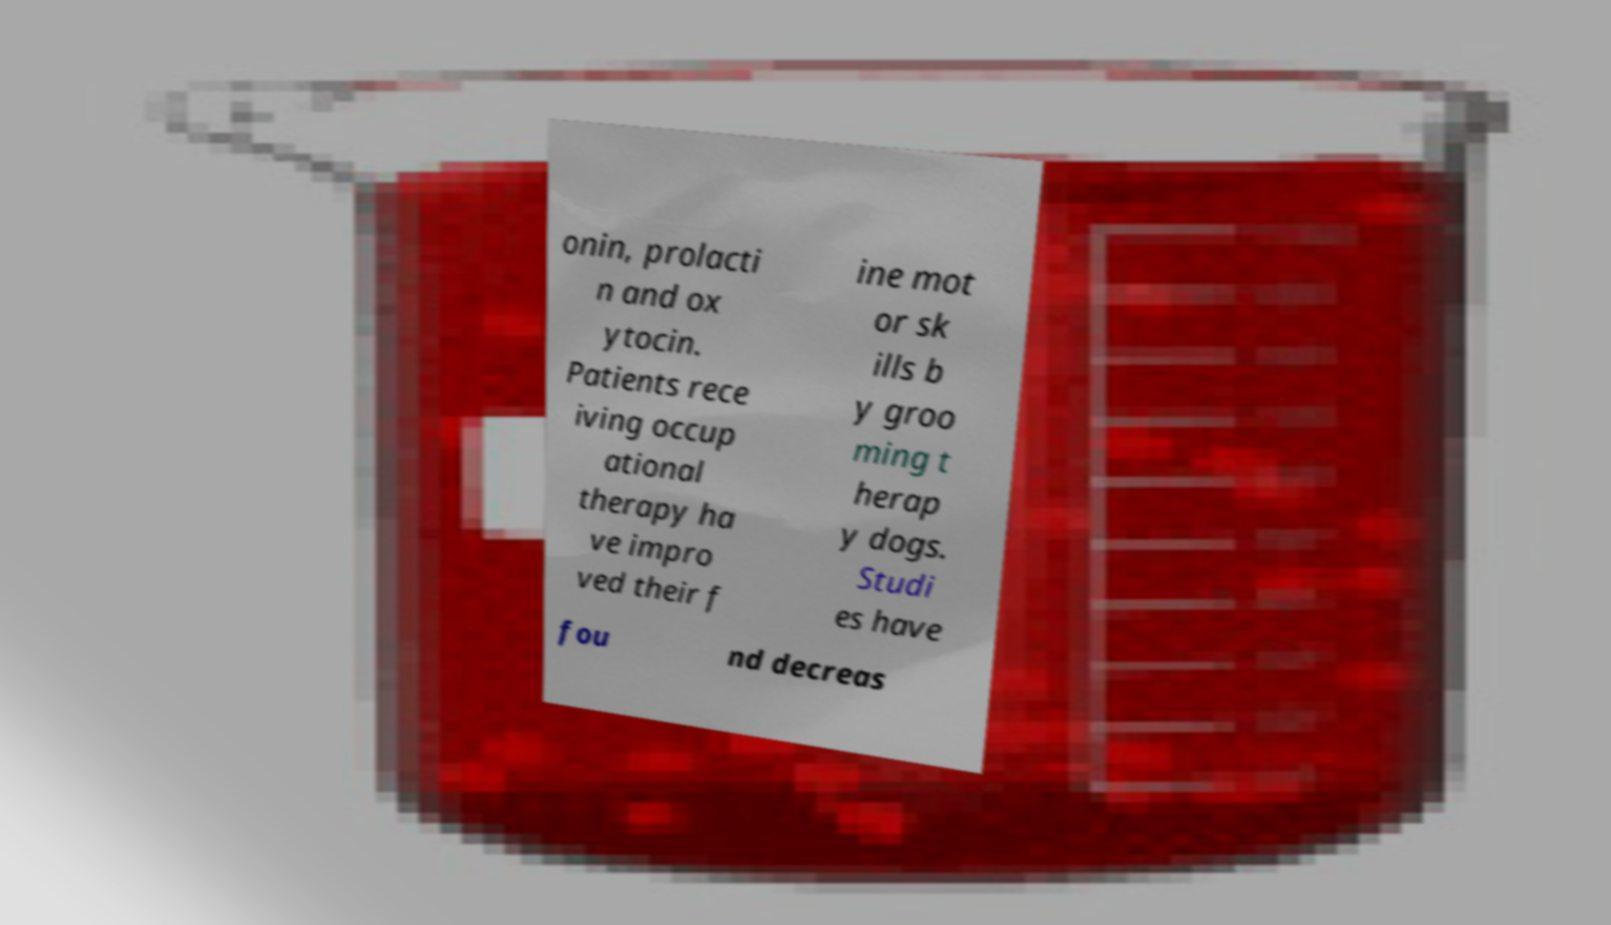Can you read and provide the text displayed in the image?This photo seems to have some interesting text. Can you extract and type it out for me? onin, prolacti n and ox ytocin. Patients rece iving occup ational therapy ha ve impro ved their f ine mot or sk ills b y groo ming t herap y dogs. Studi es have fou nd decreas 